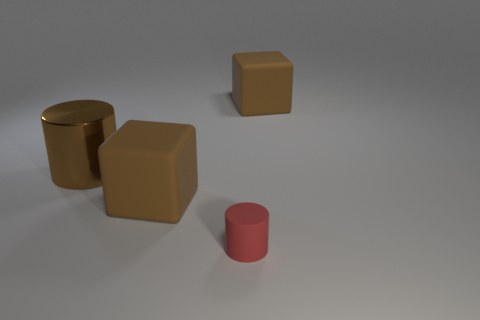How many cubes are either small yellow shiny objects or large brown objects?
Keep it short and to the point. 2. Is there a large object?
Offer a very short reply. Yes. What size is the other brown thing that is the same shape as the tiny matte object?
Provide a short and direct response. Large. There is a brown rubber thing that is in front of the big object that is right of the red cylinder; what shape is it?
Offer a very short reply. Cube. How many gray objects are either large metal cylinders or tiny cylinders?
Provide a succinct answer. 0. What is the color of the rubber cylinder?
Make the answer very short. Red. Is the red cylinder made of the same material as the cylinder that is behind the tiny object?
Keep it short and to the point. No. There is a large rubber cube in front of the shiny thing; is it the same color as the metal cylinder?
Keep it short and to the point. Yes. How many brown things are left of the tiny rubber object and behind the large brown metallic cylinder?
Make the answer very short. 0. How many other objects are the same material as the brown cylinder?
Ensure brevity in your answer.  0. 